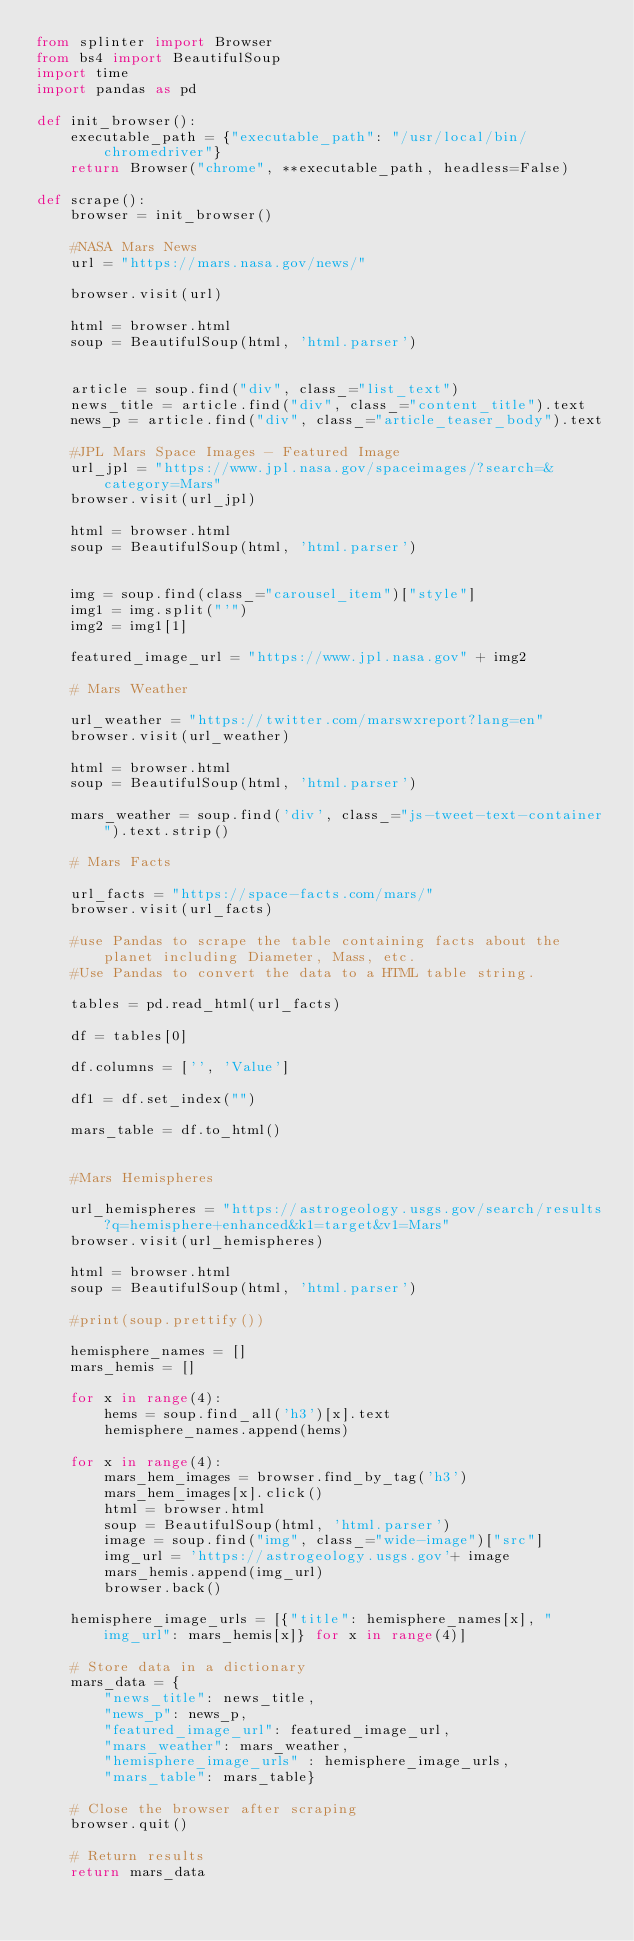Convert code to text. <code><loc_0><loc_0><loc_500><loc_500><_Python_>from splinter import Browser
from bs4 import BeautifulSoup
import time
import pandas as pd 

def init_browser():
    executable_path = {"executable_path": "/usr/local/bin/chromedriver"}
    return Browser("chrome", **executable_path, headless=False)

def scrape():
    browser = init_browser()

    #NASA Mars News 
    url = "https://mars.nasa.gov/news/"

    browser.visit(url)

    html = browser.html
    soup = BeautifulSoup(html, 'html.parser')


    article = soup.find("div", class_="list_text")
    news_title = article.find("div", class_="content_title").text
    news_p = article.find("div", class_="article_teaser_body").text

    #JPL Mars Space Images - Featured Image
    url_jpl = "https://www.jpl.nasa.gov/spaceimages/?search=&category=Mars"
    browser.visit(url_jpl)

    html = browser.html
    soup = BeautifulSoup(html, 'html.parser')


    img = soup.find(class_="carousel_item")["style"]
    img1 = img.split("'")
    img2 = img1[1]

    featured_image_url = "https://www.jpl.nasa.gov" + img2 

    # Mars Weather

    url_weather = "https://twitter.com/marswxreport?lang=en"
    browser.visit(url_weather)

    html = browser.html
    soup = BeautifulSoup(html, 'html.parser')

    mars_weather = soup.find('div', class_="js-tweet-text-container").text.strip()

    # Mars Facts

    url_facts = "https://space-facts.com/mars/"
    browser.visit(url_facts)

    #use Pandas to scrape the table containing facts about the planet including Diameter, Mass, etc.
    #Use Pandas to convert the data to a HTML table string.

    tables = pd.read_html(url_facts)

    df = tables[0]

    df.columns = ['', 'Value']

    df1 = df.set_index("")

    mars_table = df.to_html()


    #Mars Hemispheres

    url_hemispheres = "https://astrogeology.usgs.gov/search/results?q=hemisphere+enhanced&k1=target&v1=Mars"
    browser.visit(url_hemispheres)

    html = browser.html
    soup = BeautifulSoup(html, 'html.parser')

    #print(soup.prettify())

    hemisphere_names = []
    mars_hemis = []

    for x in range(4):
        hems = soup.find_all('h3')[x].text
        hemisphere_names.append(hems)

    for x in range(4):
        mars_hem_images = browser.find_by_tag('h3')
        mars_hem_images[x].click()
        html = browser.html
        soup = BeautifulSoup(html, 'html.parser')
        image = soup.find("img", class_="wide-image")["src"]
        img_url = 'https://astrogeology.usgs.gov'+ image
        mars_hemis.append(img_url)
        browser.back()

    hemisphere_image_urls = [{"title": hemisphere_names[x], "img_url": mars_hemis[x]} for x in range(4)]

    # Store data in a dictionary
    mars_data = {
        "news_title": news_title,
        "news_p": news_p,
        "featured_image_url": featured_image_url,
        "mars_weather": mars_weather,
        "hemisphere_image_urls" : hemisphere_image_urls,
        "mars_table": mars_table}
    
    # Close the browser after scraping
    browser.quit()

    # Return results
    return mars_data
</code> 